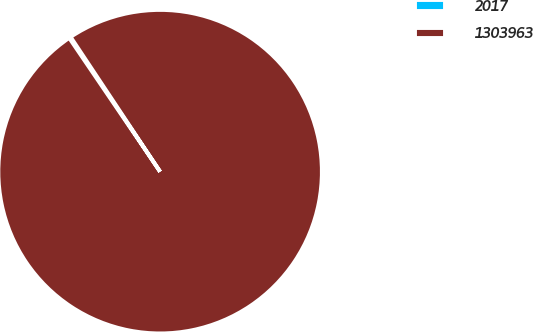Convert chart. <chart><loc_0><loc_0><loc_500><loc_500><pie_chart><fcel>2017<fcel>1303963<nl><fcel>0.17%<fcel>99.83%<nl></chart> 